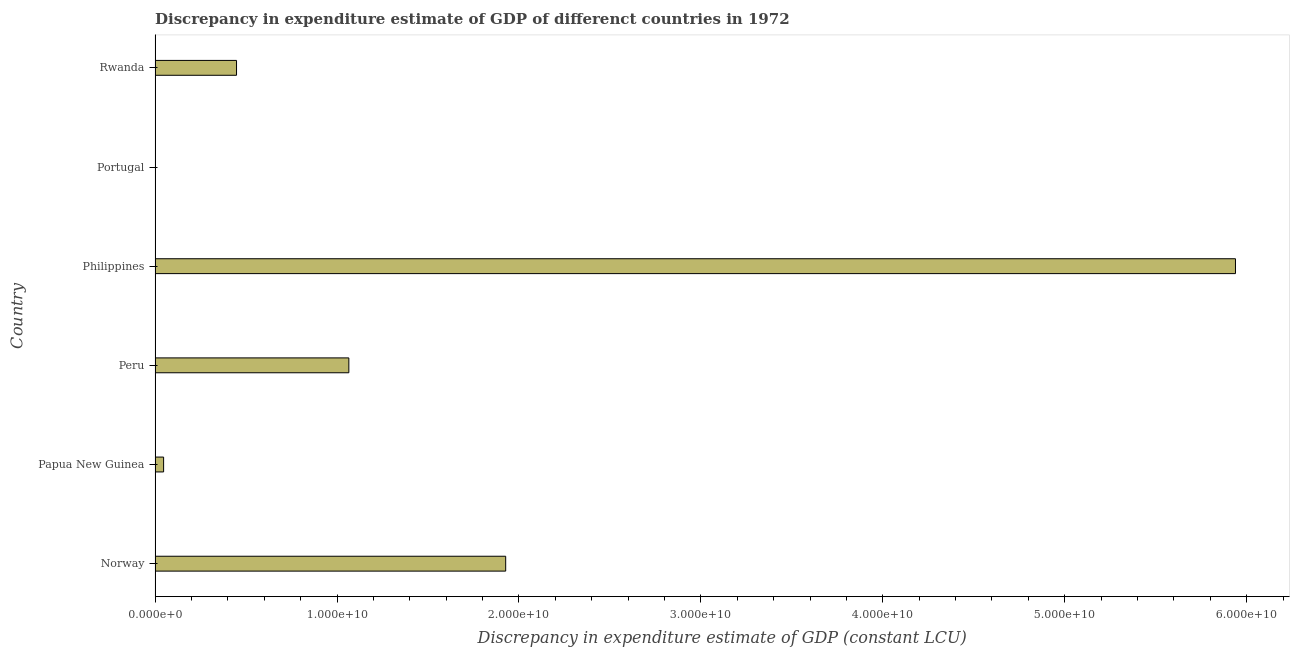Does the graph contain any zero values?
Your answer should be compact. Yes. Does the graph contain grids?
Provide a succinct answer. No. What is the title of the graph?
Provide a short and direct response. Discrepancy in expenditure estimate of GDP of differenct countries in 1972. What is the label or title of the X-axis?
Offer a terse response. Discrepancy in expenditure estimate of GDP (constant LCU). Across all countries, what is the maximum discrepancy in expenditure estimate of gdp?
Your answer should be compact. 5.94e+1. Across all countries, what is the minimum discrepancy in expenditure estimate of gdp?
Keep it short and to the point. 0. What is the sum of the discrepancy in expenditure estimate of gdp?
Ensure brevity in your answer.  9.43e+1. What is the difference between the discrepancy in expenditure estimate of gdp in Papua New Guinea and Rwanda?
Give a very brief answer. -4.01e+09. What is the average discrepancy in expenditure estimate of gdp per country?
Keep it short and to the point. 1.57e+1. What is the median discrepancy in expenditure estimate of gdp?
Ensure brevity in your answer.  7.56e+09. In how many countries, is the discrepancy in expenditure estimate of gdp greater than 16000000000 LCU?
Your response must be concise. 2. What is the ratio of the discrepancy in expenditure estimate of gdp in Peru to that in Rwanda?
Offer a terse response. 2.38. Is the discrepancy in expenditure estimate of gdp in Philippines less than that in Rwanda?
Provide a short and direct response. No. What is the difference between the highest and the second highest discrepancy in expenditure estimate of gdp?
Provide a short and direct response. 4.01e+1. Is the sum of the discrepancy in expenditure estimate of gdp in Norway and Papua New Guinea greater than the maximum discrepancy in expenditure estimate of gdp across all countries?
Offer a terse response. No. What is the difference between the highest and the lowest discrepancy in expenditure estimate of gdp?
Offer a very short reply. 5.94e+1. How many countries are there in the graph?
Keep it short and to the point. 6. What is the difference between two consecutive major ticks on the X-axis?
Your answer should be compact. 1.00e+1. Are the values on the major ticks of X-axis written in scientific E-notation?
Your answer should be very brief. Yes. What is the Discrepancy in expenditure estimate of GDP (constant LCU) of Norway?
Offer a terse response. 1.93e+1. What is the Discrepancy in expenditure estimate of GDP (constant LCU) in Papua New Guinea?
Your response must be concise. 4.70e+08. What is the Discrepancy in expenditure estimate of GDP (constant LCU) of Peru?
Provide a succinct answer. 1.07e+1. What is the Discrepancy in expenditure estimate of GDP (constant LCU) of Philippines?
Offer a terse response. 5.94e+1. What is the Discrepancy in expenditure estimate of GDP (constant LCU) in Rwanda?
Offer a very short reply. 4.48e+09. What is the difference between the Discrepancy in expenditure estimate of GDP (constant LCU) in Norway and Papua New Guinea?
Keep it short and to the point. 1.88e+1. What is the difference between the Discrepancy in expenditure estimate of GDP (constant LCU) in Norway and Peru?
Your answer should be compact. 8.62e+09. What is the difference between the Discrepancy in expenditure estimate of GDP (constant LCU) in Norway and Philippines?
Provide a succinct answer. -4.01e+1. What is the difference between the Discrepancy in expenditure estimate of GDP (constant LCU) in Norway and Rwanda?
Offer a very short reply. 1.48e+1. What is the difference between the Discrepancy in expenditure estimate of GDP (constant LCU) in Papua New Guinea and Peru?
Offer a very short reply. -1.02e+1. What is the difference between the Discrepancy in expenditure estimate of GDP (constant LCU) in Papua New Guinea and Philippines?
Provide a short and direct response. -5.89e+1. What is the difference between the Discrepancy in expenditure estimate of GDP (constant LCU) in Papua New Guinea and Rwanda?
Ensure brevity in your answer.  -4.01e+09. What is the difference between the Discrepancy in expenditure estimate of GDP (constant LCU) in Peru and Philippines?
Your response must be concise. -4.87e+1. What is the difference between the Discrepancy in expenditure estimate of GDP (constant LCU) in Peru and Rwanda?
Offer a terse response. 6.17e+09. What is the difference between the Discrepancy in expenditure estimate of GDP (constant LCU) in Philippines and Rwanda?
Offer a very short reply. 5.49e+1. What is the ratio of the Discrepancy in expenditure estimate of GDP (constant LCU) in Norway to that in Papua New Guinea?
Keep it short and to the point. 40.98. What is the ratio of the Discrepancy in expenditure estimate of GDP (constant LCU) in Norway to that in Peru?
Give a very brief answer. 1.81. What is the ratio of the Discrepancy in expenditure estimate of GDP (constant LCU) in Norway to that in Philippines?
Offer a terse response. 0.33. What is the ratio of the Discrepancy in expenditure estimate of GDP (constant LCU) in Norway to that in Rwanda?
Keep it short and to the point. 4.3. What is the ratio of the Discrepancy in expenditure estimate of GDP (constant LCU) in Papua New Guinea to that in Peru?
Provide a succinct answer. 0.04. What is the ratio of the Discrepancy in expenditure estimate of GDP (constant LCU) in Papua New Guinea to that in Philippines?
Offer a terse response. 0.01. What is the ratio of the Discrepancy in expenditure estimate of GDP (constant LCU) in Papua New Guinea to that in Rwanda?
Give a very brief answer. 0.1. What is the ratio of the Discrepancy in expenditure estimate of GDP (constant LCU) in Peru to that in Philippines?
Ensure brevity in your answer.  0.18. What is the ratio of the Discrepancy in expenditure estimate of GDP (constant LCU) in Peru to that in Rwanda?
Offer a very short reply. 2.38. What is the ratio of the Discrepancy in expenditure estimate of GDP (constant LCU) in Philippines to that in Rwanda?
Your answer should be compact. 13.26. 